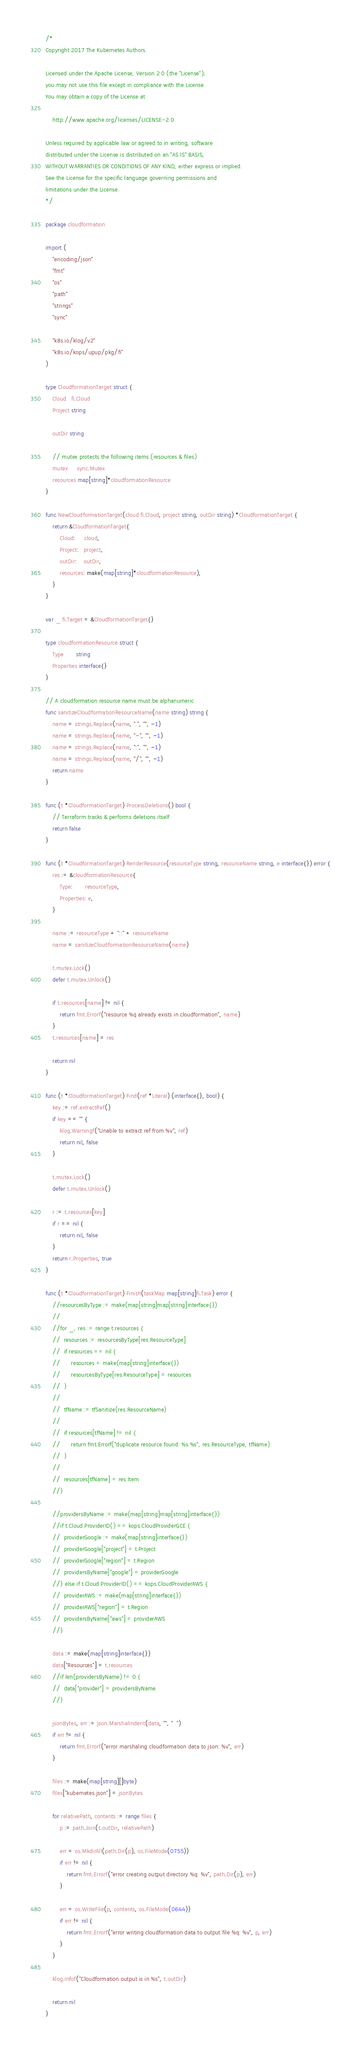<code> <loc_0><loc_0><loc_500><loc_500><_Go_>/*
Copyright 2017 The Kubernetes Authors.

Licensed under the Apache License, Version 2.0 (the "License");
you may not use this file except in compliance with the License.
You may obtain a copy of the License at

    http://www.apache.org/licenses/LICENSE-2.0

Unless required by applicable law or agreed to in writing, software
distributed under the License is distributed on an "AS IS" BASIS,
WITHOUT WARRANTIES OR CONDITIONS OF ANY KIND, either express or implied.
See the License for the specific language governing permissions and
limitations under the License.
*/

package cloudformation

import (
	"encoding/json"
	"fmt"
	"os"
	"path"
	"strings"
	"sync"

	"k8s.io/klog/v2"
	"k8s.io/kops/upup/pkg/fi"
)

type CloudformationTarget struct {
	Cloud   fi.Cloud
	Project string

	outDir string

	// mutex protects the following items (resources & files)
	mutex     sync.Mutex
	resources map[string]*cloudformationResource
}

func NewCloudformationTarget(cloud fi.Cloud, project string, outDir string) *CloudformationTarget {
	return &CloudformationTarget{
		Cloud:     cloud,
		Project:   project,
		outDir:    outDir,
		resources: make(map[string]*cloudformationResource),
	}
}

var _ fi.Target = &CloudformationTarget{}

type cloudformationResource struct {
	Type       string
	Properties interface{}
}

// A cloudformation resource name must be alphanumeric
func sanitizeCloudformationResourceName(name string) string {
	name = strings.Replace(name, ".", "", -1)
	name = strings.Replace(name, "-", "", -1)
	name = strings.Replace(name, ":", "", -1)
	name = strings.Replace(name, "/", "", -1)
	return name
}

func (t *CloudformationTarget) ProcessDeletions() bool {
	// Terraform tracks & performs deletions itself
	return false
}

func (t *CloudformationTarget) RenderResource(resourceType string, resourceName string, e interface{}) error {
	res := &cloudformationResource{
		Type:       resourceType,
		Properties: e,
	}

	name := resourceType + "::" + resourceName
	name = sanitizeCloudformationResourceName(name)

	t.mutex.Lock()
	defer t.mutex.Unlock()

	if t.resources[name] != nil {
		return fmt.Errorf("resource %q already exists in cloudformation", name)
	}
	t.resources[name] = res

	return nil
}

func (t *CloudformationTarget) Find(ref *Literal) (interface{}, bool) {
	key := ref.extractRef()
	if key == "" {
		klog.Warningf("Unable to extract ref from %v", ref)
		return nil, false
	}

	t.mutex.Lock()
	defer t.mutex.Unlock()

	r := t.resources[key]
	if r == nil {
		return nil, false
	}
	return r.Properties, true
}

func (t *CloudformationTarget) Finish(taskMap map[string]fi.Task) error {
	//resourcesByType := make(map[string]map[string]interface{})
	//
	//for _, res := range t.resources {
	//	resources := resourcesByType[res.ResourceType]
	//	if resources == nil {
	//		resources = make(map[string]interface{})
	//		resourcesByType[res.ResourceType] = resources
	//	}
	//
	//	tfName := tfSanitize(res.ResourceName)
	//
	//	if resources[tfName] != nil {
	//		return fmt.Errorf("duplicate resource found: %s.%s", res.ResourceType, tfName)
	//	}
	//
	//	resources[tfName] = res.Item
	//}

	//providersByName := make(map[string]map[string]interface{})
	//if t.Cloud.ProviderID() == kops.CloudProviderGCE {
	//	providerGoogle := make(map[string]interface{})
	//	providerGoogle["project"] = t.Project
	//	providerGoogle["region"] = t.Region
	//	providersByName["google"] = providerGoogle
	//} else if t.Cloud.ProviderID() == kops.CloudProviderAWS {
	//	providerAWS := make(map[string]interface{})
	//	providerAWS["region"] = t.Region
	//	providersByName["aws"] = providerAWS
	//}

	data := make(map[string]interface{})
	data["Resources"] = t.resources
	//if len(providersByName) != 0 {
	//	data["provider"] = providersByName
	//}

	jsonBytes, err := json.MarshalIndent(data, "", "  ")
	if err != nil {
		return fmt.Errorf("error marshaling cloudformation data to json: %v", err)
	}

	files := make(map[string][]byte)
	files["kubernetes.json"] = jsonBytes

	for relativePath, contents := range files {
		p := path.Join(t.outDir, relativePath)

		err = os.MkdirAll(path.Dir(p), os.FileMode(0755))
		if err != nil {
			return fmt.Errorf("error creating output directory %q: %v", path.Dir(p), err)
		}

		err = os.WriteFile(p, contents, os.FileMode(0644))
		if err != nil {
			return fmt.Errorf("error writing cloudformation data to output file %q: %v", p, err)
		}
	}

	klog.Infof("Cloudformation output is in %s", t.outDir)

	return nil
}
</code> 